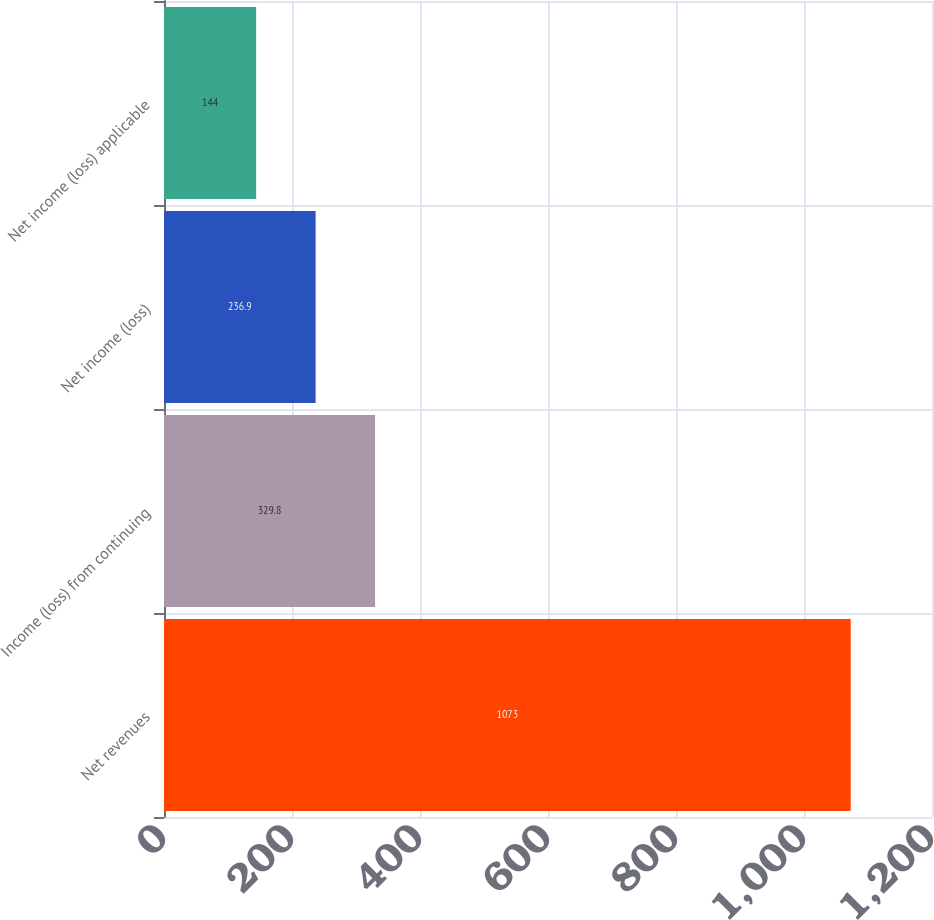Convert chart to OTSL. <chart><loc_0><loc_0><loc_500><loc_500><bar_chart><fcel>Net revenues<fcel>Income (loss) from continuing<fcel>Net income (loss)<fcel>Net income (loss) applicable<nl><fcel>1073<fcel>329.8<fcel>236.9<fcel>144<nl></chart> 